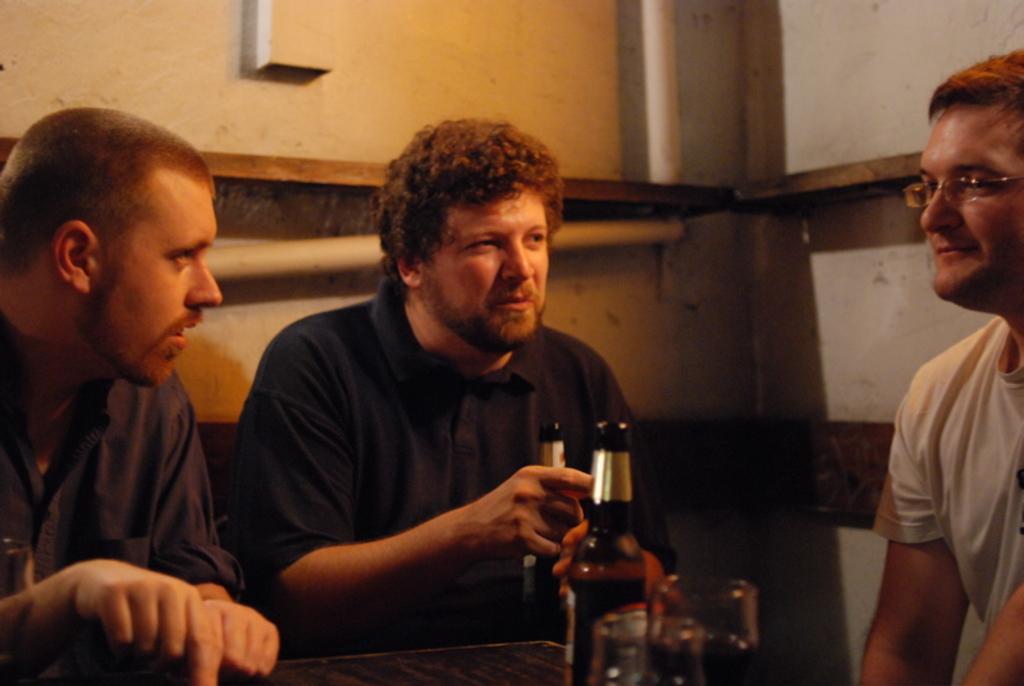How would you summarize this image in a sentence or two? this picture shows three men seated and we see a couple of bottles and glasses on the table and a man holding a beer bottle in his hand and we see a man wore spectacles on his face 